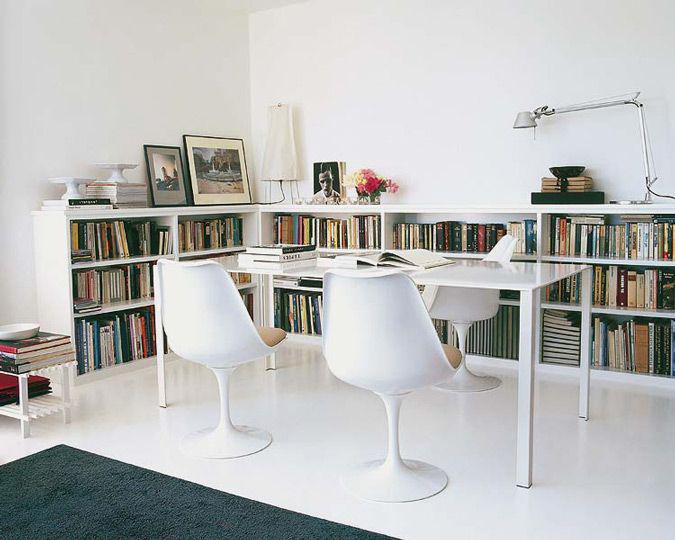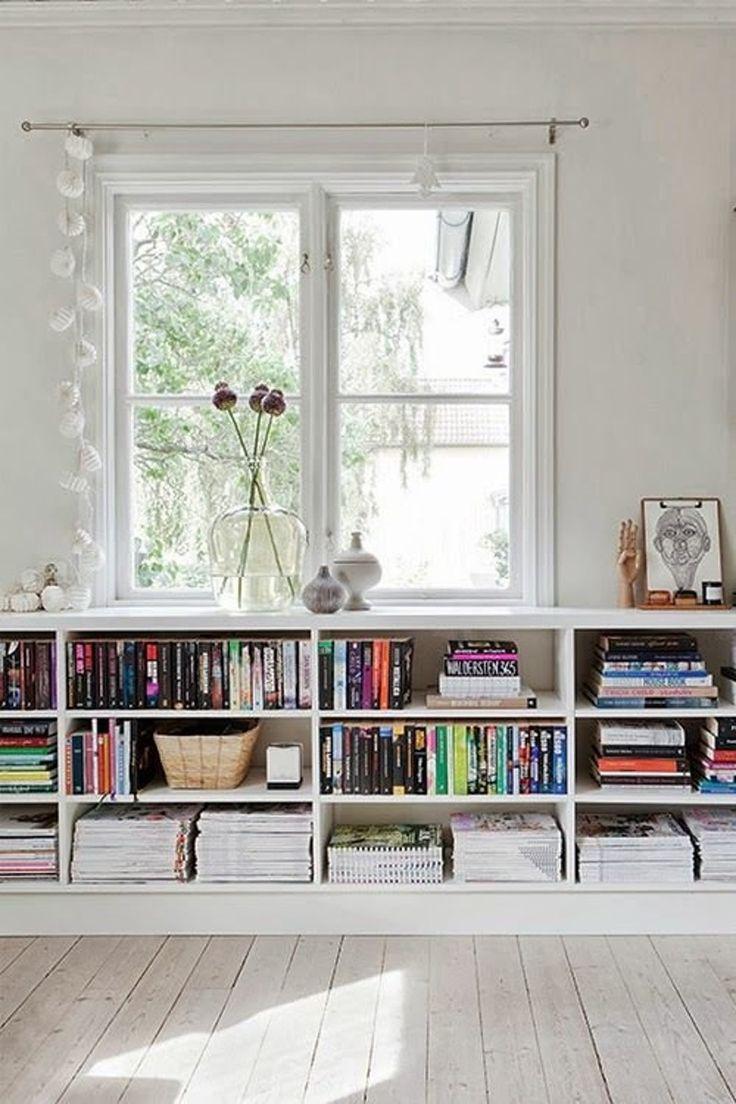The first image is the image on the left, the second image is the image on the right. Analyze the images presented: Is the assertion "At least one image shows a white low bookshelf unit that sits flush on the ground and has a variety of items displayed on its top." valid? Answer yes or no. Yes. The first image is the image on the left, the second image is the image on the right. Assess this claim about the two images: "The bookshelf in the image on the left is sitting against a white wall.". Correct or not? Answer yes or no. Yes. 